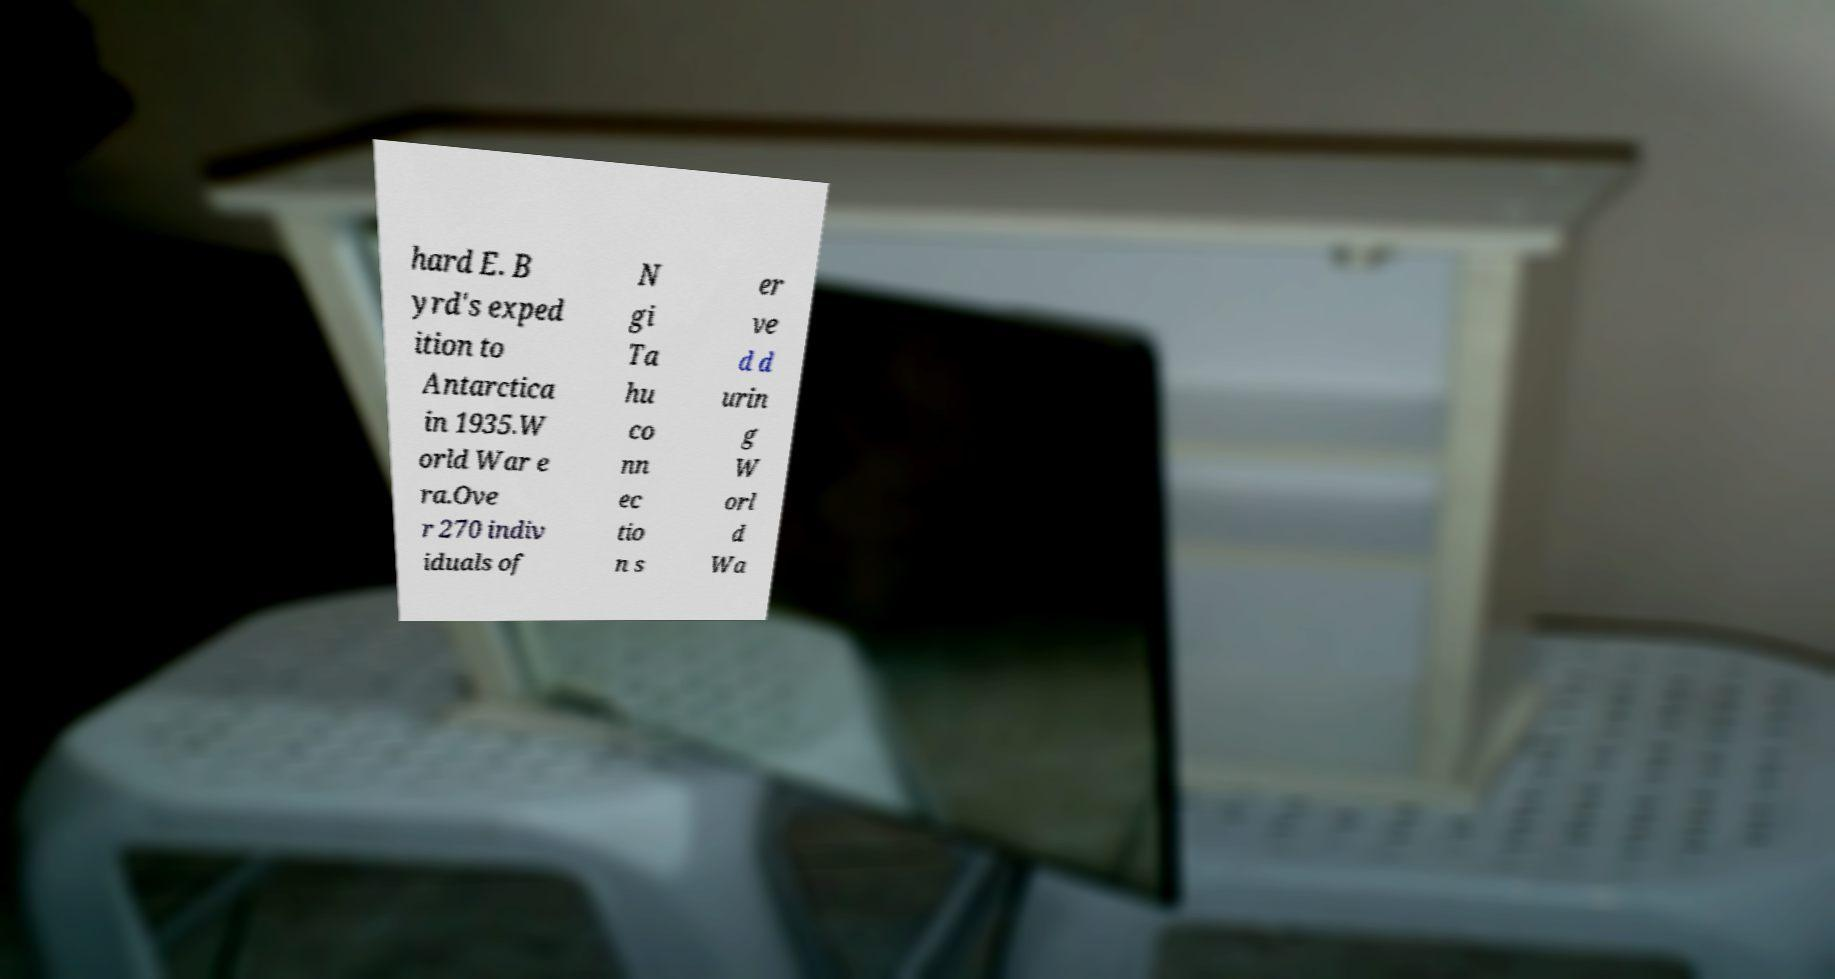Could you assist in decoding the text presented in this image and type it out clearly? hard E. B yrd's exped ition to Antarctica in 1935.W orld War e ra.Ove r 270 indiv iduals of N gi Ta hu co nn ec tio n s er ve d d urin g W orl d Wa 